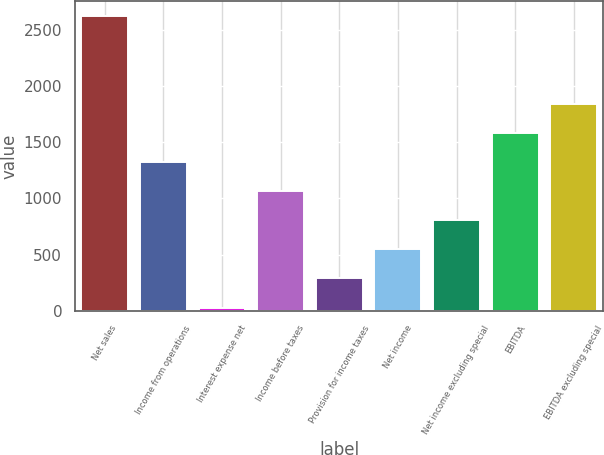<chart> <loc_0><loc_0><loc_500><loc_500><bar_chart><fcel>Net sales<fcel>Income from operations<fcel>Interest expense net<fcel>Income before taxes<fcel>Provision for income taxes<fcel>Net income<fcel>Net income excluding special<fcel>EBITDA<fcel>EBITDA excluding special<nl><fcel>2620.1<fcel>1324.65<fcel>29.2<fcel>1065.56<fcel>288.29<fcel>547.38<fcel>806.47<fcel>1583.74<fcel>1842.83<nl></chart> 